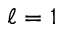Convert formula to latex. <formula><loc_0><loc_0><loc_500><loc_500>\ell = 1</formula> 